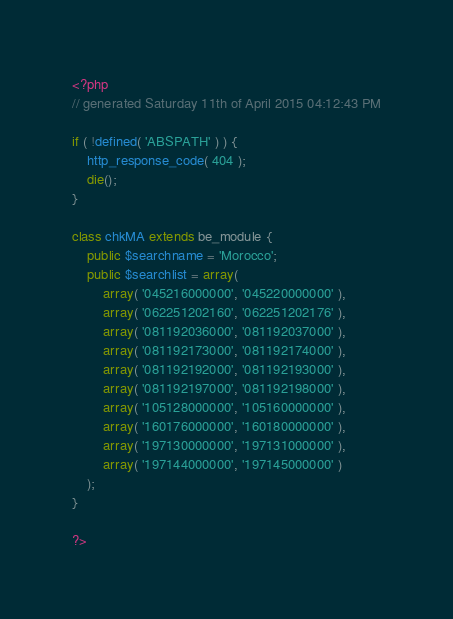Convert code to text. <code><loc_0><loc_0><loc_500><loc_500><_PHP_><?php
// generated Saturday 11th of April 2015 04:12:43 PM

if ( !defined( 'ABSPATH' ) ) {
	http_response_code( 404 );
	die();
}

class chkMA extends be_module {
	public $searchname = 'Morocco';
	public $searchlist = array(
		array( '045216000000', '045220000000' ),
		array( '062251202160', '062251202176' ),
		array( '081192036000', '081192037000' ),
		array( '081192173000', '081192174000' ),
		array( '081192192000', '081192193000' ),
		array( '081192197000', '081192198000' ),
		array( '105128000000', '105160000000' ),
		array( '160176000000', '160180000000' ),
		array( '197130000000', '197131000000' ),
		array( '197144000000', '197145000000' )
	);
}

?></code> 